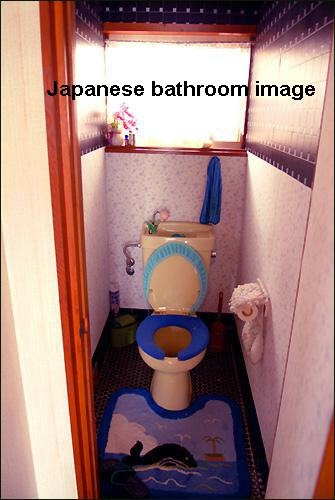Describe the objects in this image and their specific colors. I can see a toilet in black, brown, navy, tan, and maroon tones in this image. 